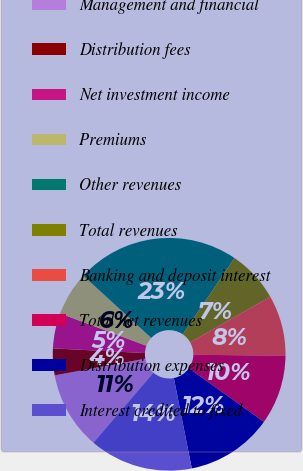Convert chart to OTSL. <chart><loc_0><loc_0><loc_500><loc_500><pie_chart><fcel>Management and financial<fcel>Distribution fees<fcel>Net investment income<fcel>Premiums<fcel>Other revenues<fcel>Total revenues<fcel>Banking and deposit interest<fcel>Total net revenues<fcel>Distribution expenses<fcel>Interest credited to fixed<nl><fcel>10.83%<fcel>3.71%<fcel>4.9%<fcel>6.09%<fcel>22.69%<fcel>7.27%<fcel>8.46%<fcel>9.64%<fcel>12.02%<fcel>14.39%<nl></chart> 